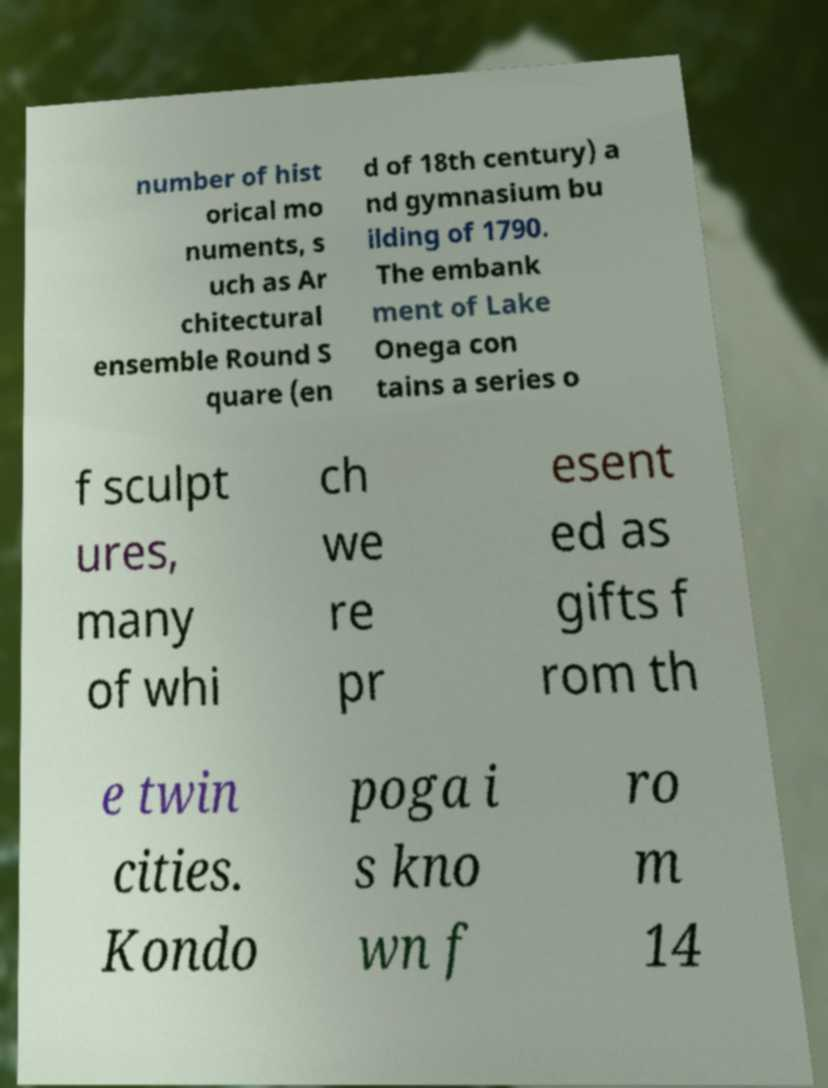Can you accurately transcribe the text from the provided image for me? number of hist orical mo numents, s uch as Ar chitectural ensemble Round S quare (en d of 18th century) a nd gymnasium bu ilding of 1790. The embank ment of Lake Onega con tains a series o f sculpt ures, many of whi ch we re pr esent ed as gifts f rom th e twin cities. Kondo poga i s kno wn f ro m 14 